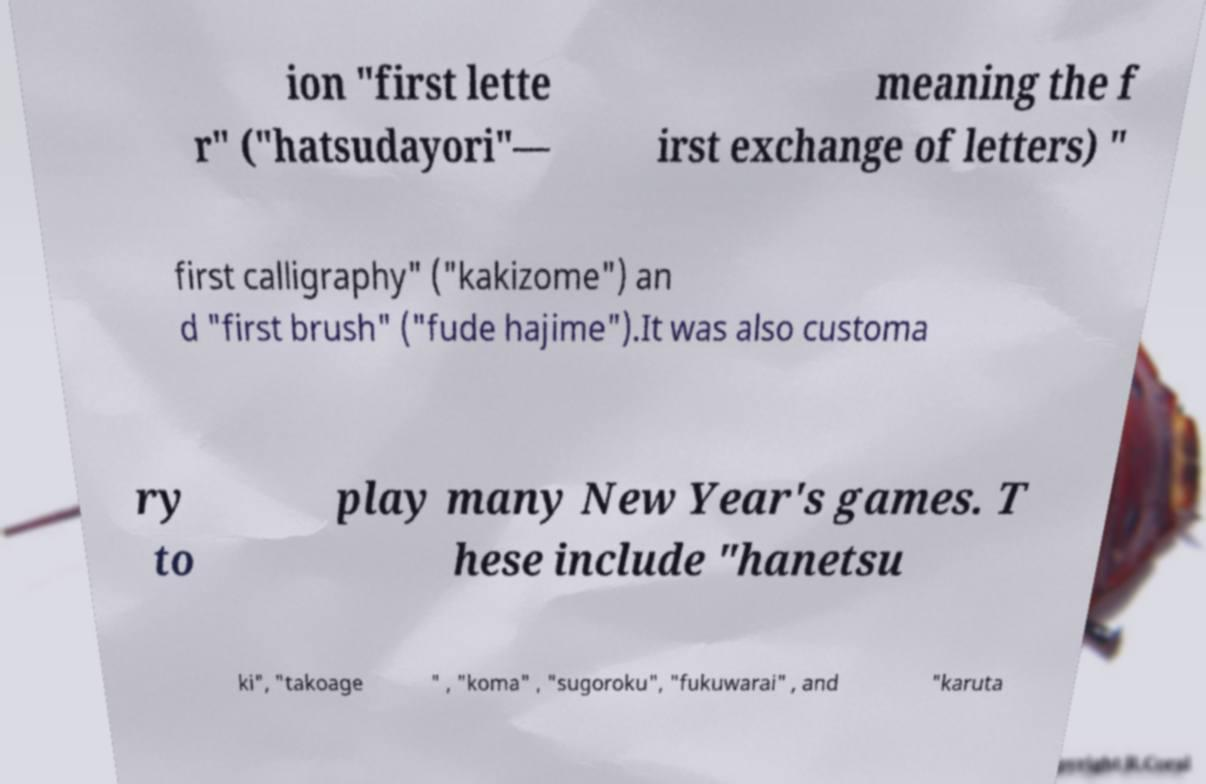Could you assist in decoding the text presented in this image and type it out clearly? ion "first lette r" ("hatsudayori"— meaning the f irst exchange of letters) " first calligraphy" ("kakizome") an d "first brush" ("fude hajime").It was also customa ry to play many New Year's games. T hese include "hanetsu ki", "takoage " , "koma" , "sugoroku", "fukuwarai" , and "karuta 